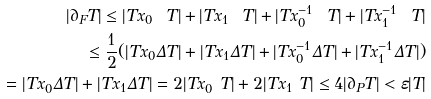Convert formula to latex. <formula><loc_0><loc_0><loc_500><loc_500>| \partial _ { F } T | \leq | T x _ { 0 } \ T | + | T x _ { 1 } \ T | + | T x _ { 0 } ^ { - 1 } \ T | + | T x _ { 1 } ^ { - 1 } \ T | \\ \leq \frac { 1 } { 2 } ( | T x _ { 0 } \Delta T | + | T x _ { 1 } \Delta T | + | T x _ { 0 } ^ { - 1 } \Delta T | + | T x _ { 1 } ^ { - 1 } \Delta T | ) \\ = | T x _ { 0 } \Delta T | + | T x _ { 1 } \Delta T | = 2 | T x _ { 0 } \ T | + 2 | T x _ { 1 } \ T | \leq 4 | \partial _ { P } T | < \varepsilon | T |</formula> 